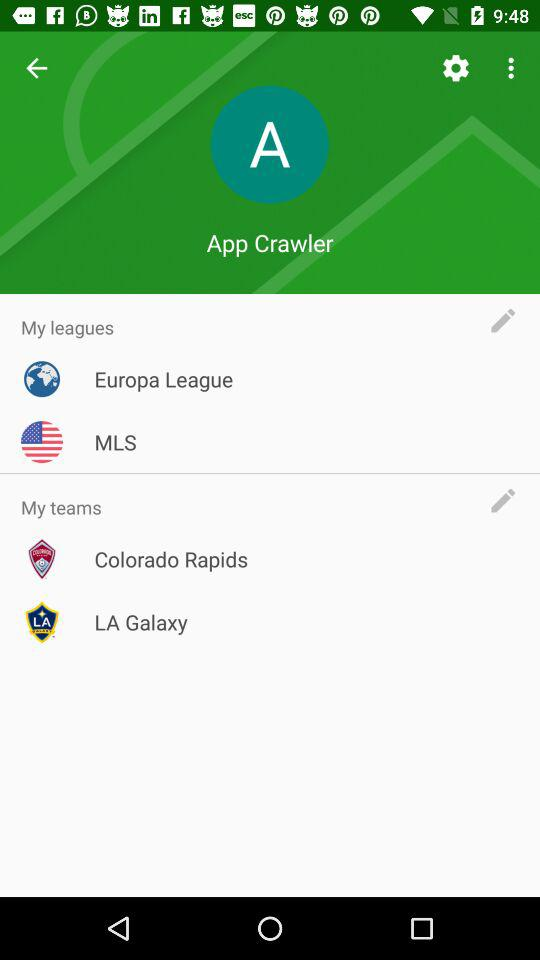How many leagues do I have?
Answer the question using a single word or phrase. 2 